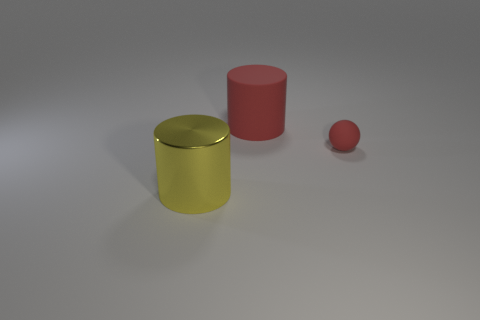Are there any other things that have the same material as the yellow cylinder?
Your answer should be very brief. No. Is the tiny red thing made of the same material as the big cylinder in front of the small rubber object?
Offer a very short reply. No. Are there fewer red matte cylinders on the left side of the red cylinder than large red matte things in front of the small red sphere?
Provide a succinct answer. No. The small object that is the same material as the large red cylinder is what color?
Offer a terse response. Red. There is a large cylinder that is in front of the large red thing; are there any metallic objects in front of it?
Your response must be concise. No. There is another cylinder that is the same size as the yellow cylinder; what is its color?
Your response must be concise. Red. What number of objects are brown metallic cubes or small matte balls?
Keep it short and to the point. 1. There is a cylinder that is in front of the matte cylinder right of the big thing that is on the left side of the red rubber cylinder; what is its size?
Ensure brevity in your answer.  Large. What number of large metal things have the same color as the matte sphere?
Provide a succinct answer. 0. What number of yellow objects are made of the same material as the yellow cylinder?
Ensure brevity in your answer.  0. 